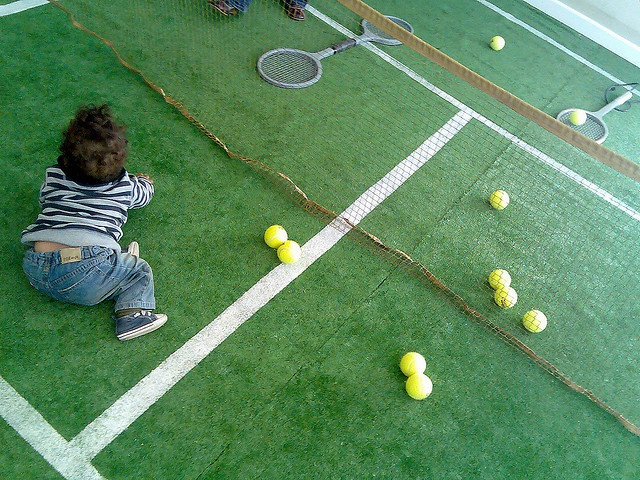Describe the objects in this image and their specific colors. I can see people in green, black, teal, darkgray, and gray tones, sports ball in green, ivory, yellow, and khaki tones, tennis racket in green, gray, darkgray, and teal tones, tennis racket in green, white, lightblue, darkgray, and teal tones, and tennis racket in green, gray, darkgray, and teal tones in this image. 